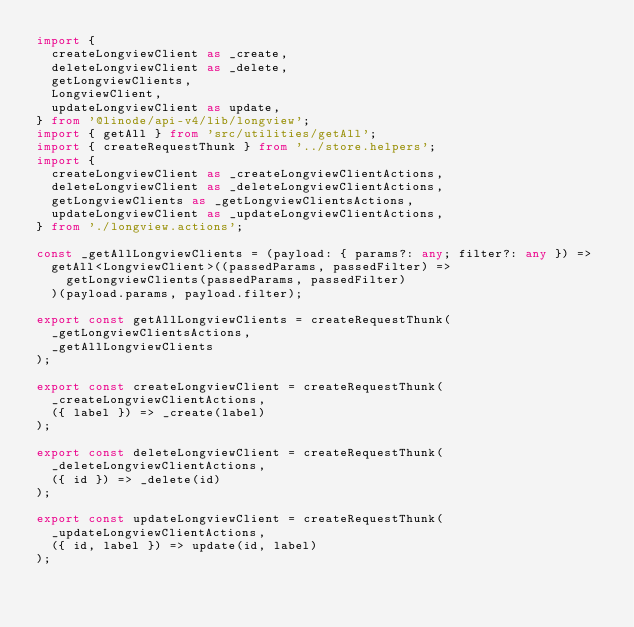Convert code to text. <code><loc_0><loc_0><loc_500><loc_500><_TypeScript_>import {
  createLongviewClient as _create,
  deleteLongviewClient as _delete,
  getLongviewClients,
  LongviewClient,
  updateLongviewClient as update,
} from '@linode/api-v4/lib/longview';
import { getAll } from 'src/utilities/getAll';
import { createRequestThunk } from '../store.helpers';
import {
  createLongviewClient as _createLongviewClientActions,
  deleteLongviewClient as _deleteLongviewClientActions,
  getLongviewClients as _getLongviewClientsActions,
  updateLongviewClient as _updateLongviewClientActions,
} from './longview.actions';

const _getAllLongviewClients = (payload: { params?: any; filter?: any }) =>
  getAll<LongviewClient>((passedParams, passedFilter) =>
    getLongviewClients(passedParams, passedFilter)
  )(payload.params, payload.filter);

export const getAllLongviewClients = createRequestThunk(
  _getLongviewClientsActions,
  _getAllLongviewClients
);

export const createLongviewClient = createRequestThunk(
  _createLongviewClientActions,
  ({ label }) => _create(label)
);

export const deleteLongviewClient = createRequestThunk(
  _deleteLongviewClientActions,
  ({ id }) => _delete(id)
);

export const updateLongviewClient = createRequestThunk(
  _updateLongviewClientActions,
  ({ id, label }) => update(id, label)
);
</code> 